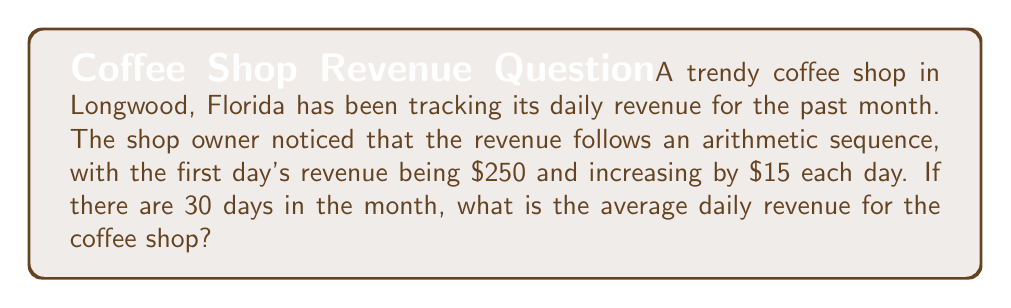Can you solve this math problem? Let's approach this step-by-step:

1) First, we need to find the last day's revenue. In an arithmetic sequence:
   $a_n = a_1 + (n-1)d$
   where $a_n$ is the nth term, $a_1$ is the first term, n is the number of terms, and d is the common difference.

   $a_{30} = 250 + (30-1)15 = 250 + 435 = 685$

2) Now we have the first term ($a_1 = 250$) and the last term ($a_{30} = 685$) of the sequence.

3) The sum of an arithmetic sequence is given by:
   $S_n = \frac{n}{2}(a_1 + a_n)$
   where $S_n$ is the sum of n terms, $a_1$ is the first term, and $a_n$ is the last term.

4) Substituting our values:
   $S_{30} = \frac{30}{2}(250 + 685) = 15(935) = 14,025$

5) To find the average daily revenue, we divide the total revenue by the number of days:
   $\text{Average} = \frac{S_{30}}{30} = \frac{14,025}{30} = 467.50$

Therefore, the average daily revenue for the coffee shop over the month is $467.50.
Answer: $467.50 